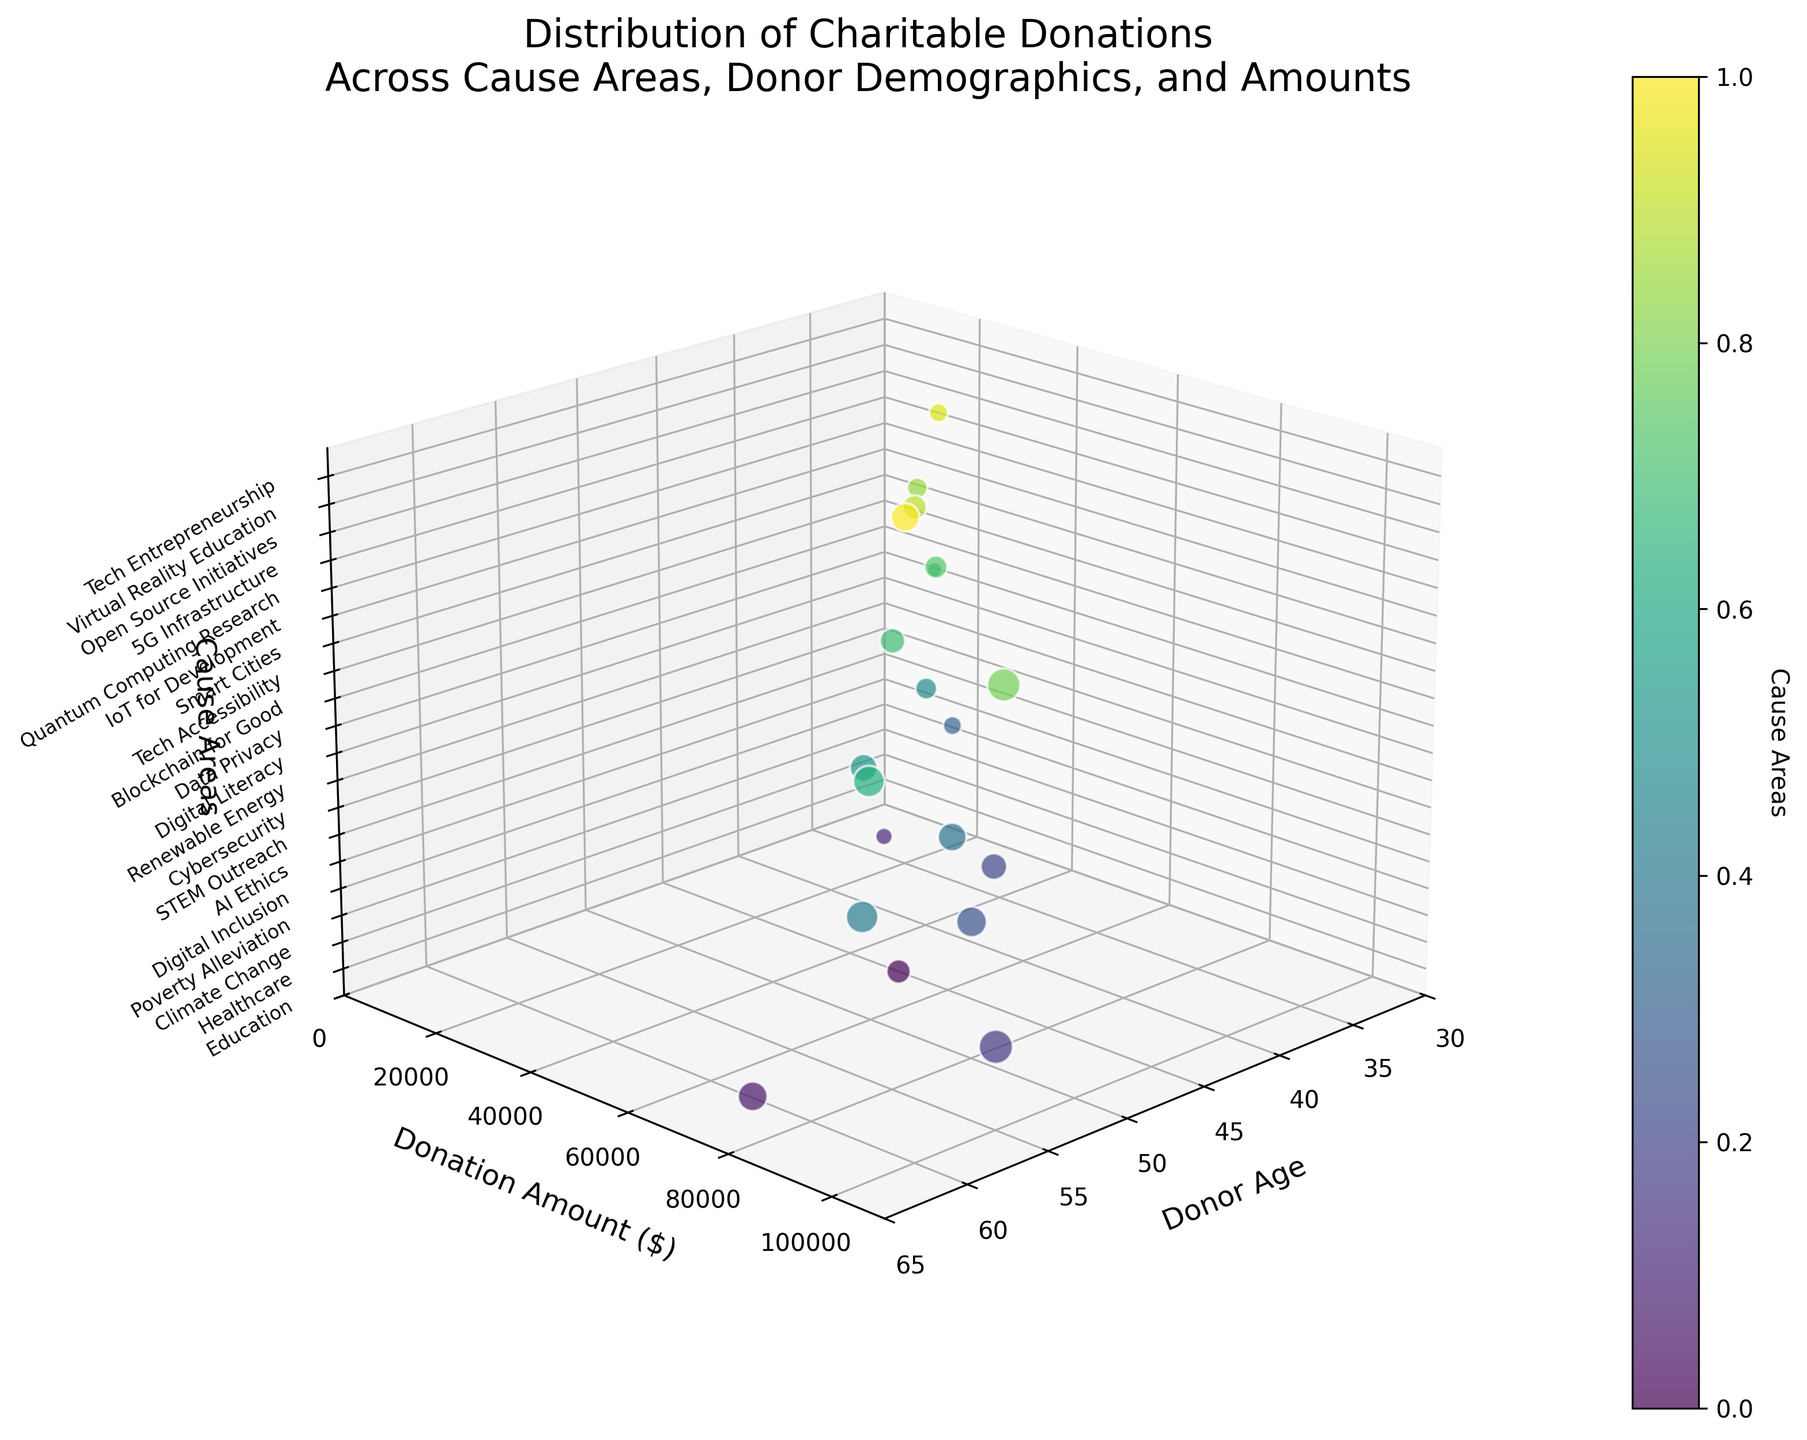What title is given to the figure? The title is provided at the top of the figure and states the main theme and context of the data presented. It reads "Distribution of Charitable Donations Across Cause Areas, Donor Demographics, and Amounts."
Answer: Distribution of Charitable Donations Across Cause Areas, Donor Demographics, and Amounts What do the axes labels indicate? Each axis label describes a different dimension of the data. The x-axis represents 'Donor Age', the y-axis represents 'Donation Amount ($)', and the z-axis signifies 'Cause Areas.' These labels clarify what data is being measured and compared.
Answer: Donor Age, Donation Amount ($), Cause Areas How many cause areas are represented in the figure? The z-axis has distinct ticks and labels representing each cause area. By counting these labels, we find there are 20 unique cause areas included.
Answer: 20 Which cause area corresponds to the highest donation amount? Observing the data points on the y-axis (Donation Amount) and z-axis (Cause Areas), the highest donation amount ($100,000) corresponds with the label 'Poverty Alleviation.'
Answer: Poverty Alleviation What is the average donation amount across all cause areas? To determine the average, sum up all donation amounts provided and divide by the total number of cause areas (20). The calculation is (50000 + 75000 + 25000 + 100000 + 60000 + 80000 + 30000 + 70000 + 90000 + 40000 + 65000 + 20000 + 85000 + 55000 + 45000 + 95000 + 35000 + 50000 + 30000 + 70000) / 20 = 60750.
Answer: $60,750 What is the difference in donation amounts between AI Ethics and Blockchain for Good? The donation amount for AI Ethics is $80,000, and for Blockchain for Good is $20,000. The difference is calculated as $80,000 - $20,000 = $60,000.
Answer: $60,000 Which donor age group made the smallest donation? By looking at the smallest y-axis value and locating its corresponding x-axis (Donor Age), the smallest donation amount of $20,000 was made by the donor age group of 33 (Blockchain for Good).
Answer: 33 How do donation amounts typically vary with donor age? Observing the scatter plot as a whole, it appears that there is no clear linear trend; donations vary widely across different ages. Therefore, there isn't a simple correlation between donor age and donation size.
Answer: No clear trend Which cause areas have donations of over $80,000? By identifying points on the y-axis (Donation Amount) that are above $80,000 and checking their corresponding z-axis labels, we find that the causes are 'Poverty Alleviation', 'Quantum Computing Research', 'Tech Accessibility', and 'Renewable Energy.'
Answer: Poverty Alleviation, Quantum Computing Research, Tech Accessibility, Renewable Energy 